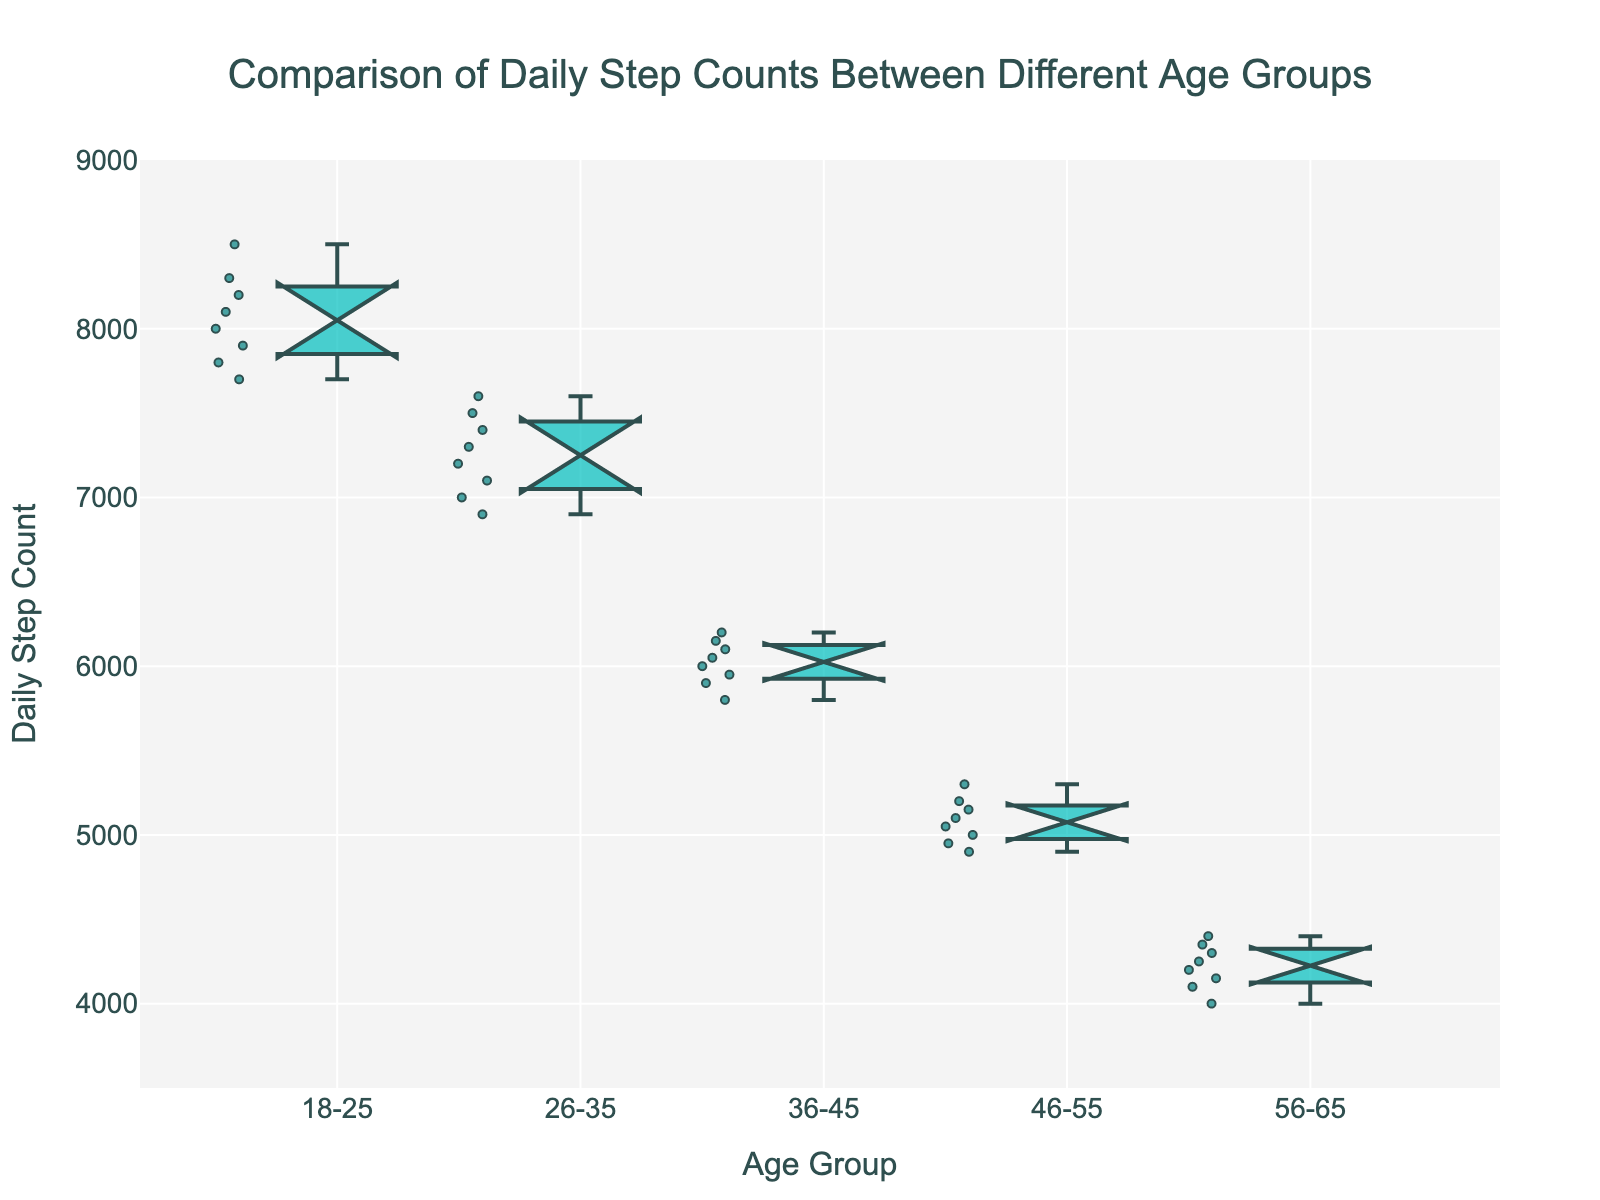What's the title of the plot? The title of the plot is located at the top center and indicates the main topic being visualized. The title reads "Comparison of Daily Step Counts Between Different Age Groups", giving a summary of the data being depicted in the notched box plot.
Answer: Comparison of Daily Step Counts Between Different Age Groups What is the y-axis title of the plot? The y-axis title provides information about what the y-axis represents. It is labeled as "Daily Step Count," indicating that the vertical axis measures the number of steps taken daily by individuals in each age group.
Answer: Daily Step Count Which age group has the highest median daily step count? To find the age group with the highest median daily step count, look for the box plot where the horizontal line inside the box (the median line) is positioned highest on the y-axis. Here, the age group "18-25" has the highest median line.
Answer: 18-25 What is the approximate range of daily step counts for the 36-45 age group? The range of the step counts for the 36-45 age group can be determined by looking at the top and bottom of the box, which represents the interquartile range (IQR), as well as the whiskers. The range goes roughly from 5800 to 6200 steps.
Answer: 5800 to 6200 steps Among the age groups, which one shows the smallest interquartile range (IQR) in daily step counts? The interquartile range (IQR) is represented by the height of the box, which includes the middle 50% of the data. The smallest IQR box can be seen in the "56-65" age group.
Answer: 56-65 Are there any overlapping notches between different age groups? Notched box plots use notches to represent the confidence interval around the median. If notches overlap between different age groups, it suggests that the medians of those groups are statistically similar. There are some overlaps visible between the "26-35" and "36-45" age groups and also between the "36-45" and "46-55" age groups.
Answer: Yes Which age group has the lowest daily step count observations? The lowest daily step count observations can be seen at the bottom whisker of the lowest box plot. The "56-65" age group has the lowest step counts, with the lowest point being around 4000 steps.
Answer: 56-65 What can you infer about the daily step counts in the "46-55" age group compared to the "18-25" age group? By comparing the positions of the boxes and median lines, we can say that the "46-55" age group has a lower median and overall lower step counts compared to the "18-25" age group. The "46-55" group's median line is positioned considerably lower, suggesting they walk fewer steps daily.
Answer: The "46-55" age group has lower daily step counts than the "18-25" age group Is there a consistent trend in daily step counts as age increases? By observing the box plots from "18-25" to "56-65", we notice a general downward trend in both median steps and the spread of the data. This suggests that as age increases, daily step counts tend to decrease.
Answer: Yes 